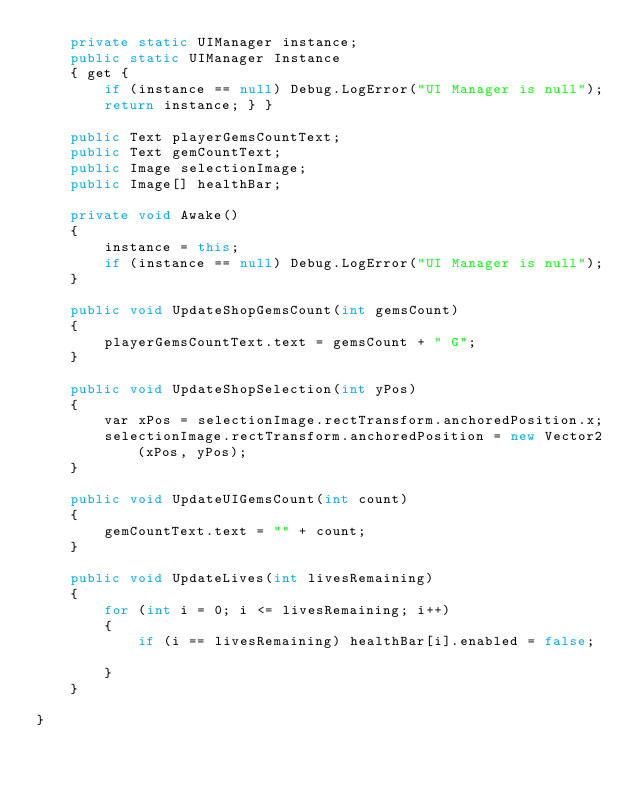Convert code to text. <code><loc_0><loc_0><loc_500><loc_500><_C#_>    private static UIManager instance;
    public static UIManager Instance
    { get {
        if (instance == null) Debug.LogError("UI Manager is null");
        return instance; } }

    public Text playerGemsCountText;
    public Text gemCountText;
    public Image selectionImage;
    public Image[] healthBar;

    private void Awake()
    {
        instance = this;
        if (instance == null) Debug.LogError("UI Manager is null");
    }

    public void UpdateShopGemsCount(int gemsCount)
    {
        playerGemsCountText.text = gemsCount + " G";
    }

    public void UpdateShopSelection(int yPos)
    {
        var xPos = selectionImage.rectTransform.anchoredPosition.x;
        selectionImage.rectTransform.anchoredPosition = new Vector2(xPos, yPos);
    }

    public void UpdateUIGemsCount(int count)
    {
        gemCountText.text = "" + count;
    }

    public void UpdateLives(int livesRemaining)
    {
        for (int i = 0; i <= livesRemaining; i++)
        {
            if (i == livesRemaining) healthBar[i].enabled = false;

        } 
    }
    
}
</code> 